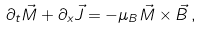Convert formula to latex. <formula><loc_0><loc_0><loc_500><loc_500>\partial _ { t } \vec { M } + \partial _ { x } \vec { J } = - \mu _ { B } \vec { M } \times \vec { B } \, ,</formula> 